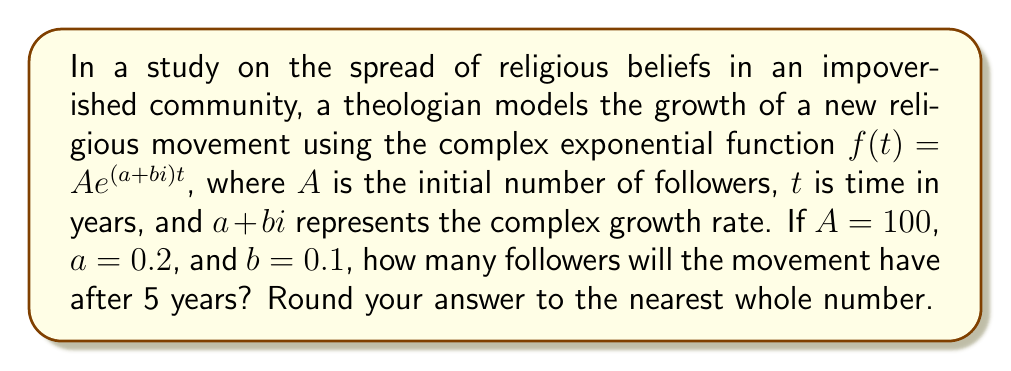Teach me how to tackle this problem. Let's approach this step-by-step:

1) We are given the function $f(t) = Ae^{(a+bi)t}$ with the following values:
   $A = 100$
   $a = 0.2$
   $b = 0.1$
   $t = 5$ (we want to know the result after 5 years)

2) Substituting these values into the function:
   $f(5) = 100e^{(0.2+0.1i)5}$

3) Simplify the exponent:
   $f(5) = 100e^{1+0.5i}$

4) To evaluate this, we can use Euler's formula: $e^{x+yi} = e^x(\cos y + i\sin y)$

5) In our case, $x = 1$ and $y = 0.5$:
   $f(5) = 100e^1(\cos 0.5 + i\sin 0.5)$

6) Calculate $e^1 \approx 2.71828$

7) Calculate $\cos 0.5 \approx 0.87758$ and $\sin 0.5 \approx 0.47943$

8) Substituting these values:
   $f(5) = 100 * 2.71828 * (0.87758 + 0.47943i)$

9) Multiply:
   $f(5) = 271.828 * (0.87758 + 0.47943i)$
   $f(5) = 238.55 + 130.31i$

10) The magnitude of this complex number represents the number of followers:
    $|f(5)| = \sqrt{238.55^2 + 130.31^2} \approx 271.82$

11) Rounding to the nearest whole number: 272
Answer: 272 followers 